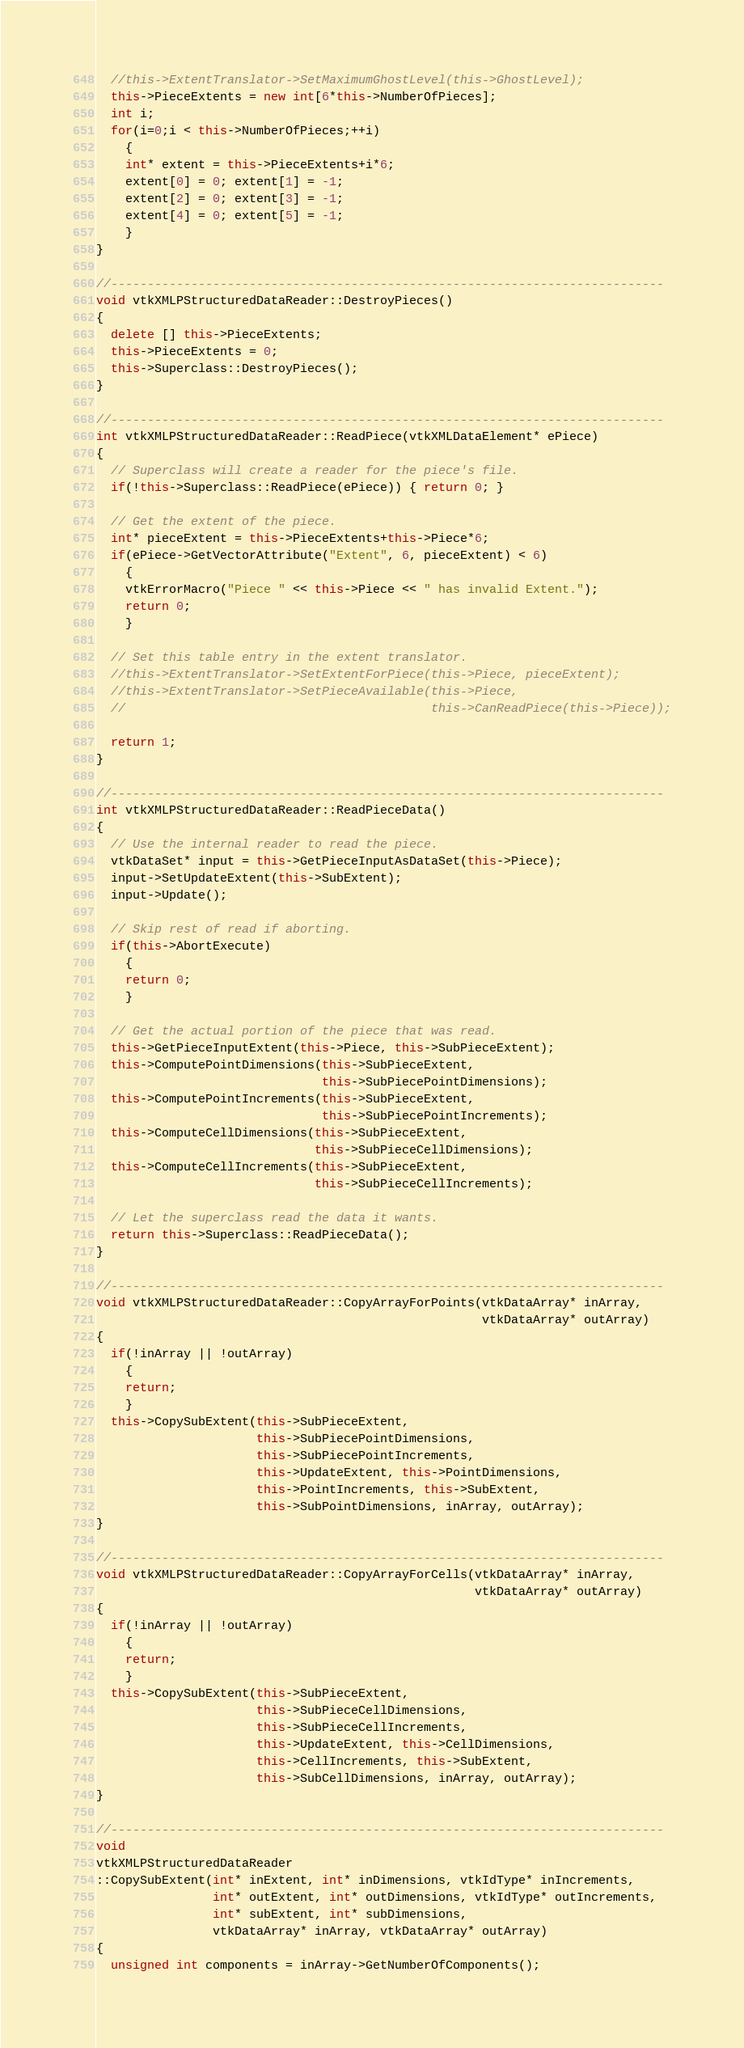Convert code to text. <code><loc_0><loc_0><loc_500><loc_500><_C++_>  //this->ExtentTranslator->SetMaximumGhostLevel(this->GhostLevel);
  this->PieceExtents = new int[6*this->NumberOfPieces];
  int i;
  for(i=0;i < this->NumberOfPieces;++i)
    {
    int* extent = this->PieceExtents+i*6;
    extent[0] = 0; extent[1] = -1;
    extent[2] = 0; extent[3] = -1;
    extent[4] = 0; extent[5] = -1;
    }
}

//----------------------------------------------------------------------------
void vtkXMLPStructuredDataReader::DestroyPieces()
{
  delete [] this->PieceExtents;
  this->PieceExtents = 0;
  this->Superclass::DestroyPieces();
}

//----------------------------------------------------------------------------
int vtkXMLPStructuredDataReader::ReadPiece(vtkXMLDataElement* ePiece)
{
  // Superclass will create a reader for the piece's file.
  if(!this->Superclass::ReadPiece(ePiece)) { return 0; }
  
  // Get the extent of the piece.
  int* pieceExtent = this->PieceExtents+this->Piece*6;
  if(ePiece->GetVectorAttribute("Extent", 6, pieceExtent) < 6)
    {
    vtkErrorMacro("Piece " << this->Piece << " has invalid Extent.");
    return 0;
    }
  
  // Set this table entry in the extent translator.
  //this->ExtentTranslator->SetExtentForPiece(this->Piece, pieceExtent);
  //this->ExtentTranslator->SetPieceAvailable(this->Piece,
  //                                          this->CanReadPiece(this->Piece));
  
  return 1;
}

//----------------------------------------------------------------------------
int vtkXMLPStructuredDataReader::ReadPieceData()
{  
  // Use the internal reader to read the piece.
  vtkDataSet* input = this->GetPieceInputAsDataSet(this->Piece);
  input->SetUpdateExtent(this->SubExtent);
  input->Update();
  
  // Skip rest of read if aborting.
  if(this->AbortExecute)
    {
    return 0;
    }
  
  // Get the actual portion of the piece that was read.
  this->GetPieceInputExtent(this->Piece, this->SubPieceExtent);
  this->ComputePointDimensions(this->SubPieceExtent,
                               this->SubPiecePointDimensions);
  this->ComputePointIncrements(this->SubPieceExtent,
                               this->SubPiecePointIncrements);
  this->ComputeCellDimensions(this->SubPieceExtent,
                              this->SubPieceCellDimensions);
  this->ComputeCellIncrements(this->SubPieceExtent,
                              this->SubPieceCellIncrements);
  
  // Let the superclass read the data it wants.
  return this->Superclass::ReadPieceData();
}

//----------------------------------------------------------------------------
void vtkXMLPStructuredDataReader::CopyArrayForPoints(vtkDataArray* inArray,
                                                     vtkDataArray* outArray)
{
  if(!inArray || !outArray)
    {
    return;
    }
  this->CopySubExtent(this->SubPieceExtent,
                      this->SubPiecePointDimensions,
                      this->SubPiecePointIncrements,
                      this->UpdateExtent, this->PointDimensions,
                      this->PointIncrements, this->SubExtent,
                      this->SubPointDimensions, inArray, outArray);
}

//----------------------------------------------------------------------------
void vtkXMLPStructuredDataReader::CopyArrayForCells(vtkDataArray* inArray,
                                                    vtkDataArray* outArray)
{
  if(!inArray || !outArray)
    {
    return;
    }
  this->CopySubExtent(this->SubPieceExtent,
                      this->SubPieceCellDimensions,
                      this->SubPieceCellIncrements,
                      this->UpdateExtent, this->CellDimensions,
                      this->CellIncrements, this->SubExtent,
                      this->SubCellDimensions, inArray, outArray);
}

//----------------------------------------------------------------------------
void
vtkXMLPStructuredDataReader
::CopySubExtent(int* inExtent, int* inDimensions, vtkIdType* inIncrements,
                int* outExtent, int* outDimensions, vtkIdType* outIncrements,
                int* subExtent, int* subDimensions,
                vtkDataArray* inArray, vtkDataArray* outArray)
{
  unsigned int components = inArray->GetNumberOfComponents();</code> 